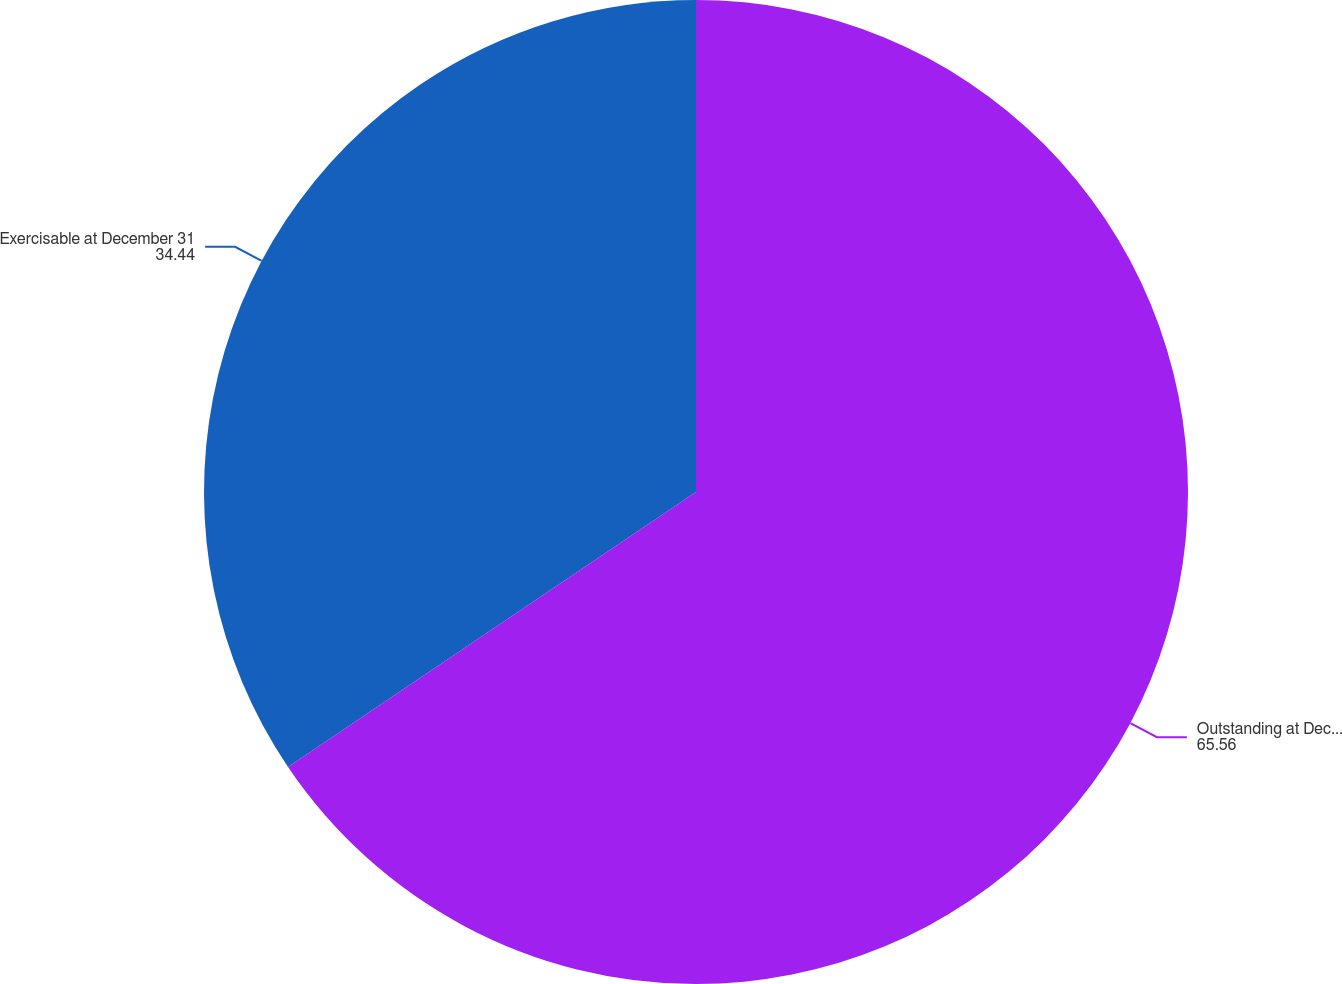<chart> <loc_0><loc_0><loc_500><loc_500><pie_chart><fcel>Outstanding at December 31<fcel>Exercisable at December 31<nl><fcel>65.56%<fcel>34.44%<nl></chart> 